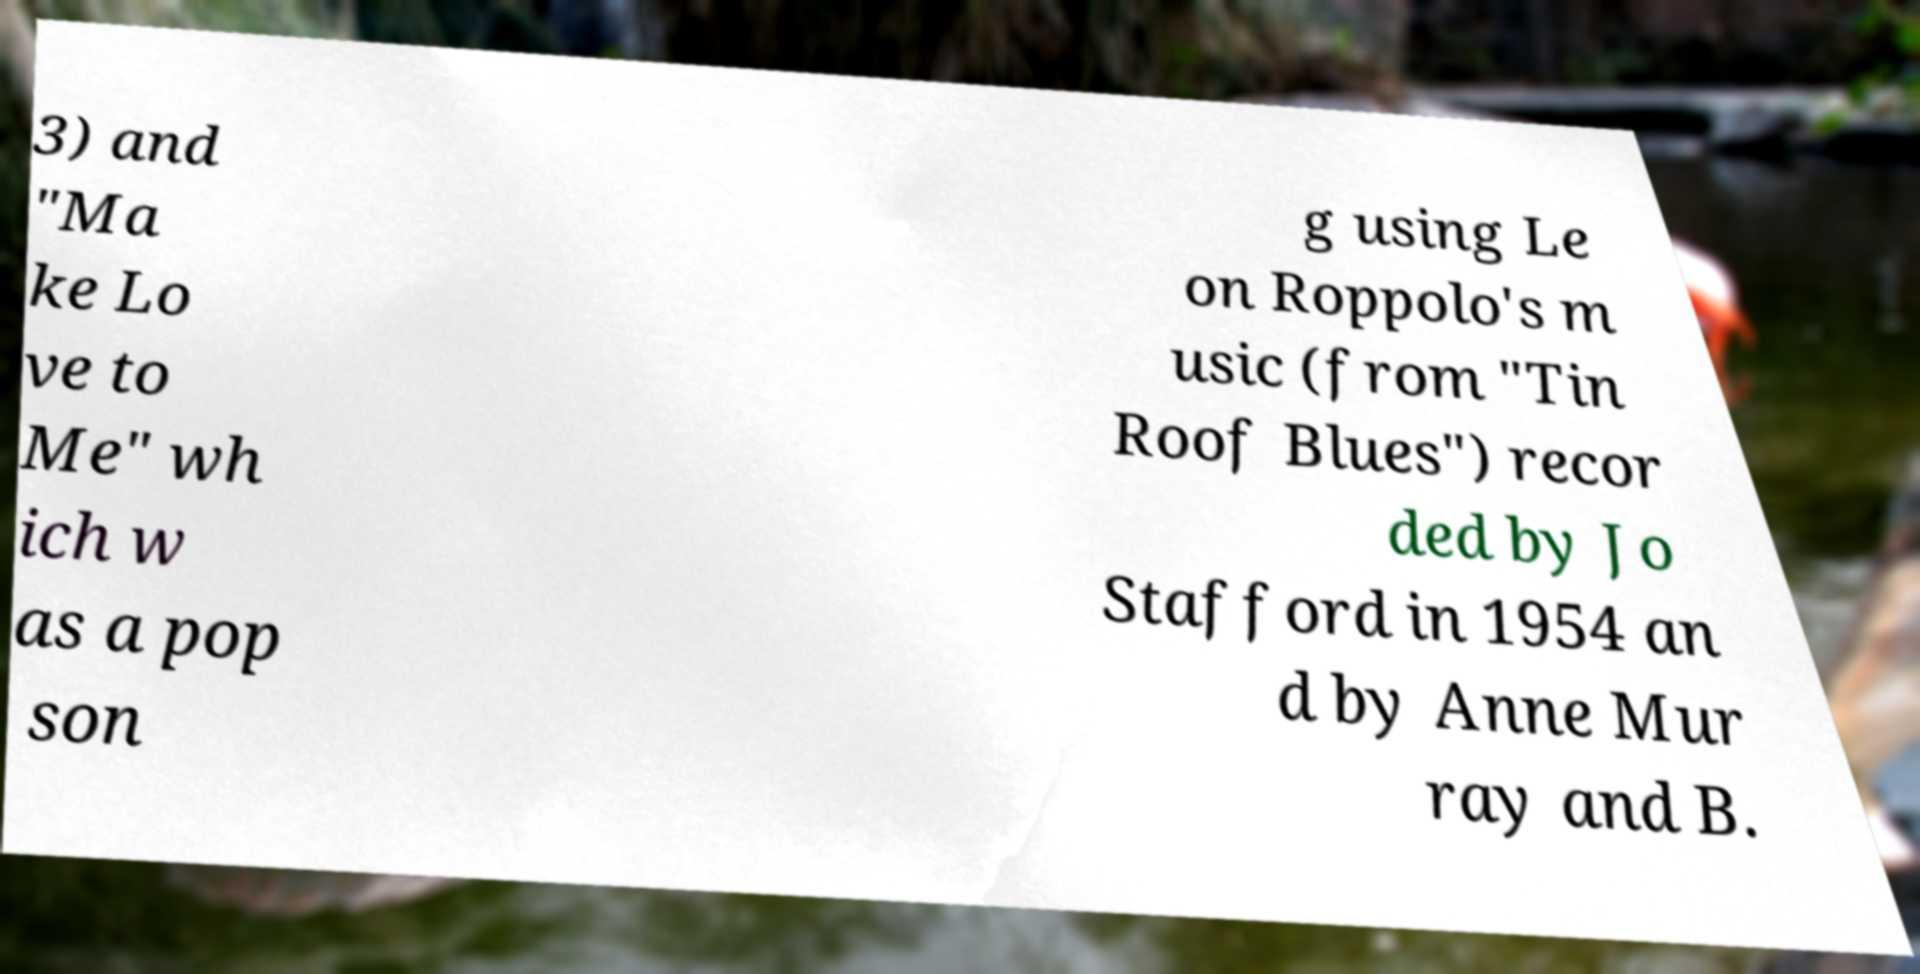I need the written content from this picture converted into text. Can you do that? 3) and "Ma ke Lo ve to Me" wh ich w as a pop son g using Le on Roppolo's m usic (from "Tin Roof Blues") recor ded by Jo Stafford in 1954 an d by Anne Mur ray and B. 